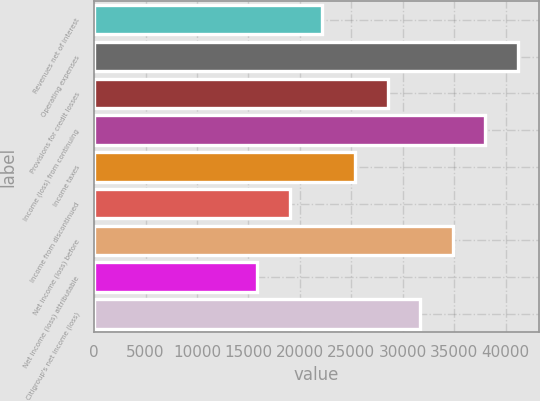Convert chart to OTSL. <chart><loc_0><loc_0><loc_500><loc_500><bar_chart><fcel>Revenues net of interest<fcel>Operating expenses<fcel>Provisions for credit losses<fcel>Income (loss) from continuing<fcel>Income taxes<fcel>Income from discontinued<fcel>Net income (loss) before<fcel>Net income (loss) attributable<fcel>Citigroup's net income (loss)<nl><fcel>22184.7<fcel>41197.3<fcel>28522.2<fcel>38028.5<fcel>25353.5<fcel>19016<fcel>34859.8<fcel>15847.2<fcel>31691<nl></chart> 